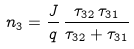Convert formula to latex. <formula><loc_0><loc_0><loc_500><loc_500>n _ { 3 } = \frac { J } { q } \, \frac { \tau _ { 3 2 } \, \tau _ { 3 1 } } { \tau _ { 3 2 } + \tau _ { 3 1 } }</formula> 